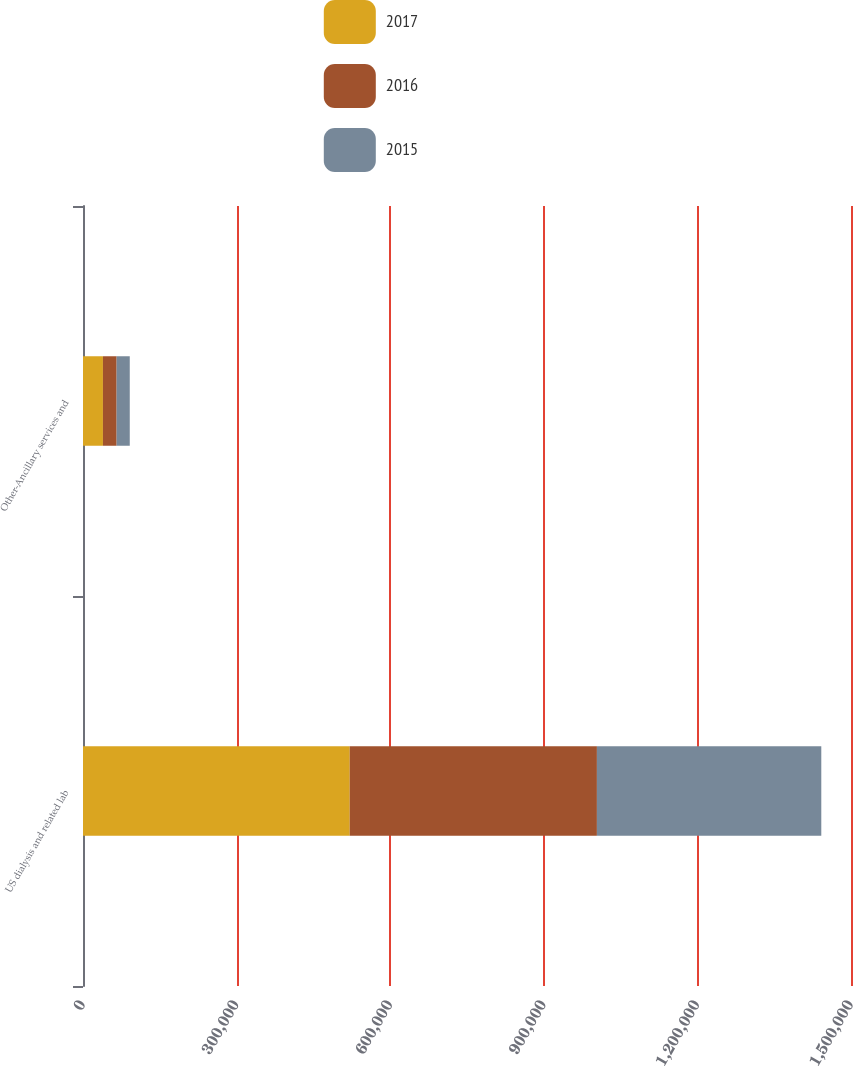Convert chart. <chart><loc_0><loc_0><loc_500><loc_500><stacked_bar_chart><ecel><fcel>US dialysis and related lab<fcel>Other-Ancillary services and<nl><fcel>2017<fcel>520965<fcel>38946<nl><fcel>2016<fcel>482768<fcel>26729<nl><fcel>2015<fcel>438238<fcel>25667<nl></chart> 